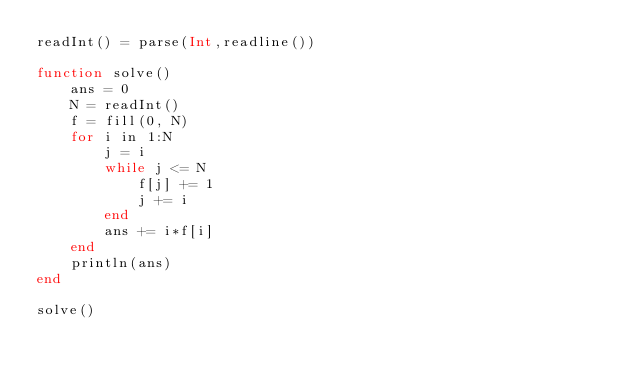<code> <loc_0><loc_0><loc_500><loc_500><_Julia_>readInt() = parse(Int,readline())

function solve()
    ans = 0
    N = readInt()
    f = fill(0, N)
    for i in 1:N
        j = i
        while j <= N
            f[j] += 1
            j += i
        end
        ans += i*f[i]
    end
    println(ans)
end

solve()</code> 